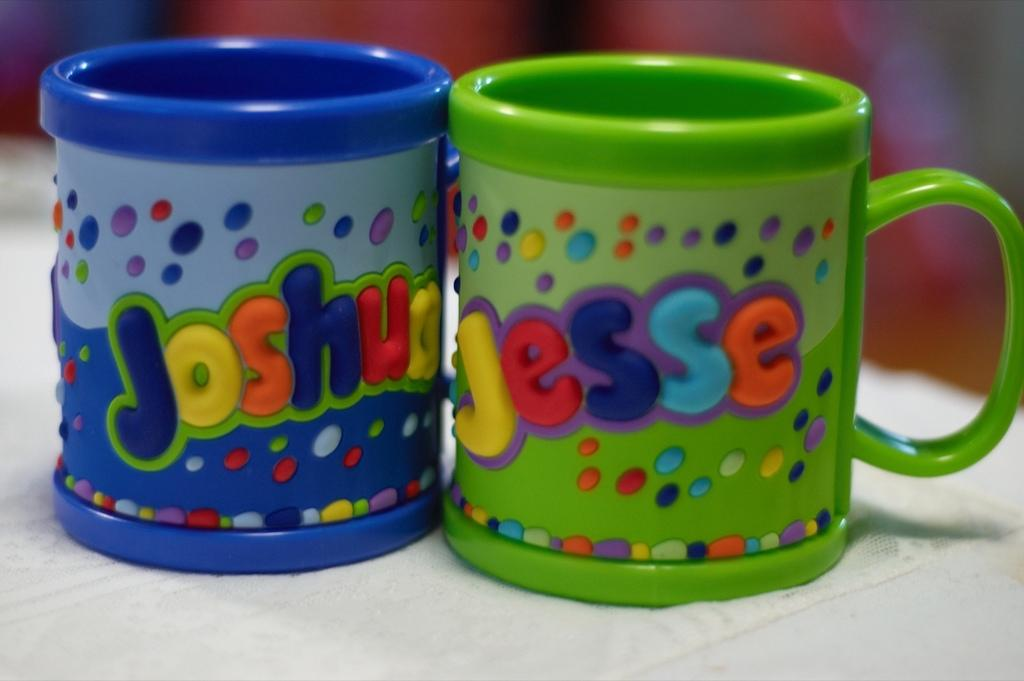<image>
Provide a brief description of the given image. Two cups with the names Joshua and Jesse next to each other 